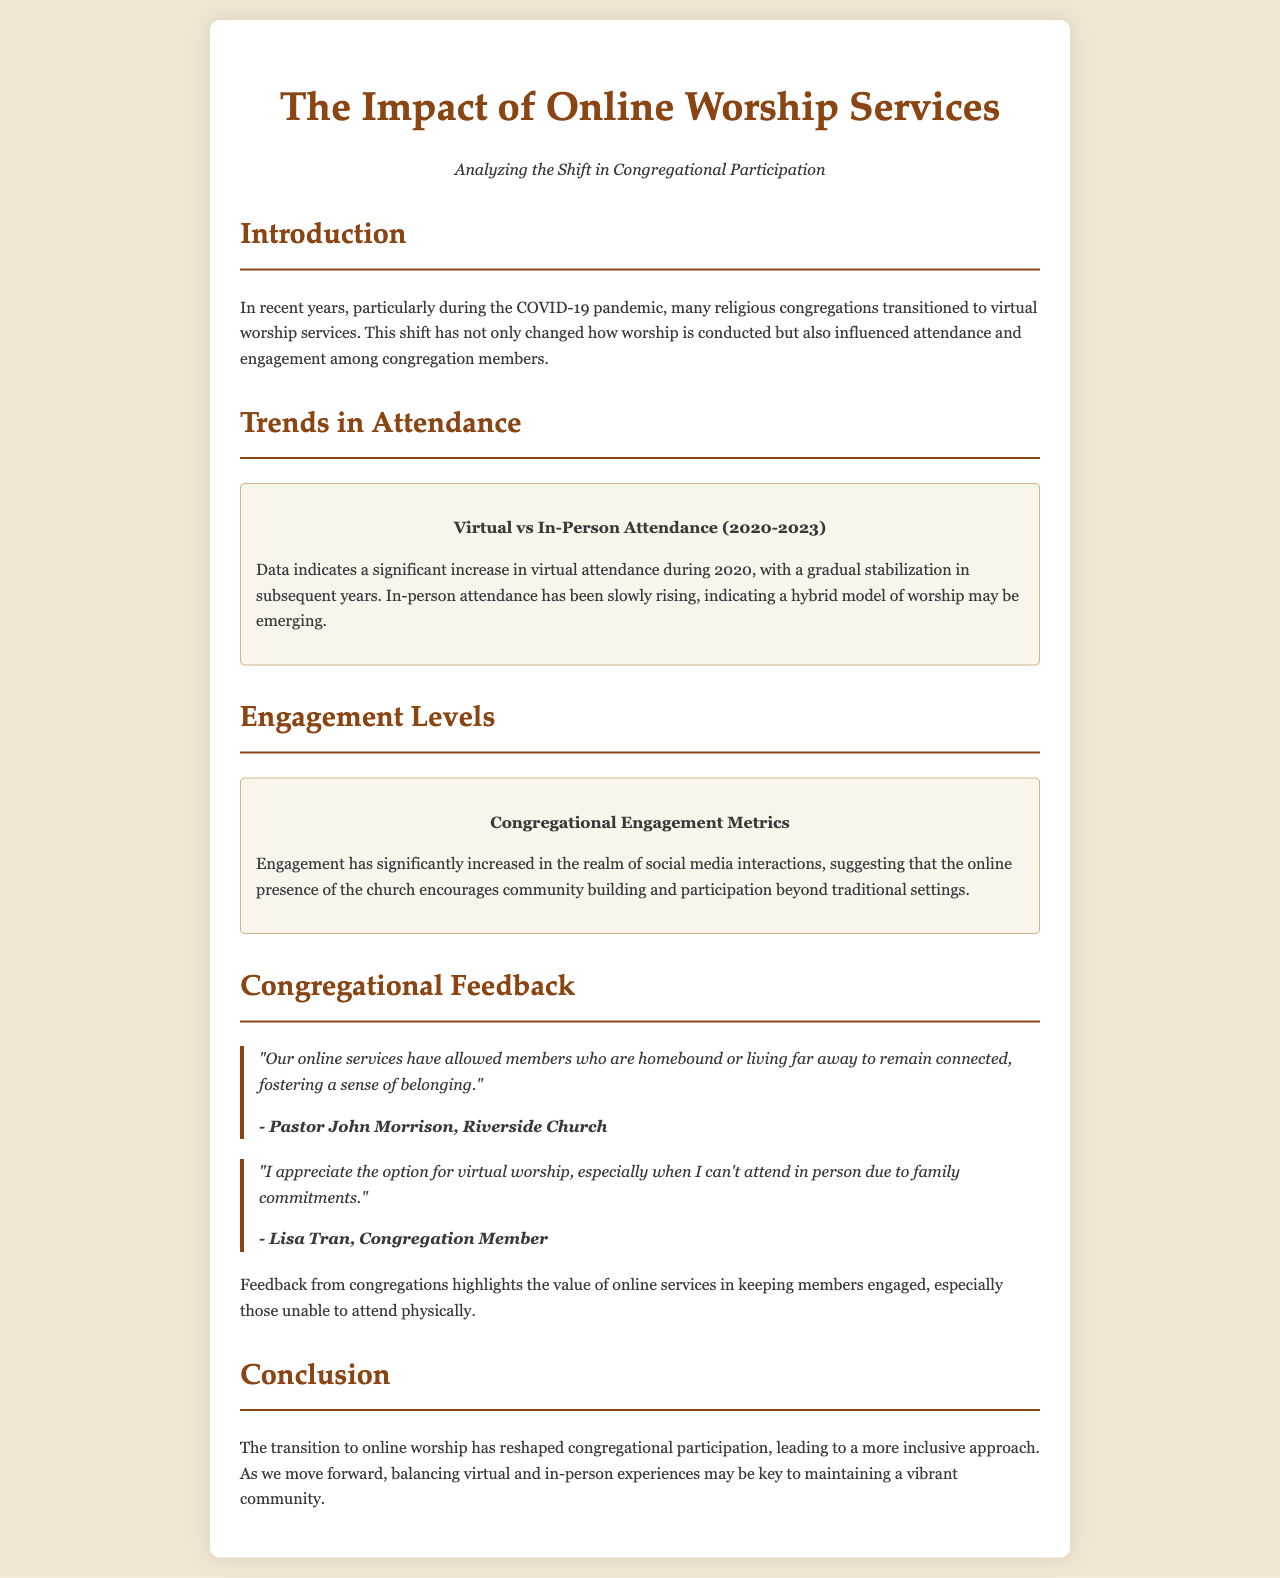what is the subtitle of the brochure? The subtitle is presented in the document right below the title and states the focus of the analysis.
Answer: Analyzing the Shift in Congregational Participation what year signifies a significant increase in virtual attendance? The document highlights the year when virtual attendance saw a marked rise due to the pandemic.
Answer: 2020 who is quoted about the value of online services for homebound members? The quote provides insight on community engagement from a key figure within a congregational setting.
Answer: Pastor John Morrison what trend is observed in in-person attendance according to the document? The document explains the trend observed in physical attendance at worship services over the years.
Answer: Slowly rising which metric has significantly increased in relation to social media? The document summarizes the engagement levels, emphasizing a specific area of growth.
Answer: Social media interactions what does the conclusion suggest about the future of worship services? The conclusion reflects on the balance between different worship formats and community participation.
Answer: Balancing virtual and in-person experiences 